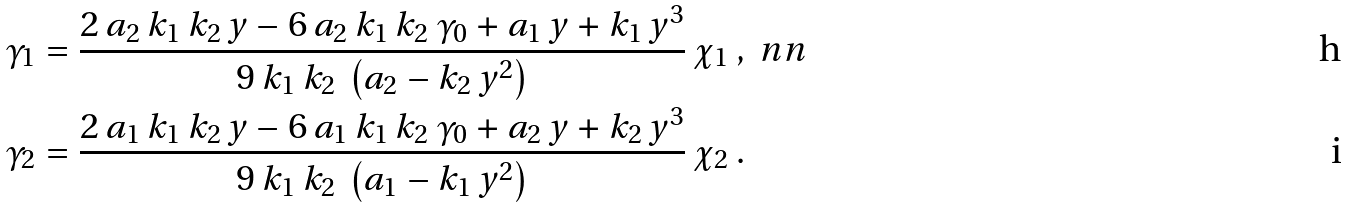Convert formula to latex. <formula><loc_0><loc_0><loc_500><loc_500>\gamma _ { 1 } & = \frac { 2 \, a _ { 2 } \, k _ { 1 } \, k _ { 2 } \, y - 6 \, a _ { 2 } \, k _ { 1 } \, k _ { 2 } \, \gamma _ { 0 } + a _ { 1 } \, y + k _ { 1 } \, y ^ { 3 } } { 9 \, k _ { 1 } \, k _ { 2 } \, \left ( a _ { 2 } - k _ { 2 } \, y ^ { 2 } \right ) } \, \chi _ { 1 } \ , \ n n \\ \gamma _ { 2 } & = \frac { 2 \, a _ { 1 } \, k _ { 1 } \, k _ { 2 } \, y - 6 \, a _ { 1 } \, k _ { 1 } \, k _ { 2 } \, \gamma _ { 0 } + a _ { 2 } \, y + k _ { 2 } \, y ^ { 3 } } { 9 \, k _ { 1 } \, k _ { 2 } \, \left ( a _ { 1 } - k _ { 1 } \, y ^ { 2 } \right ) } \, \chi _ { 2 } \ .</formula> 